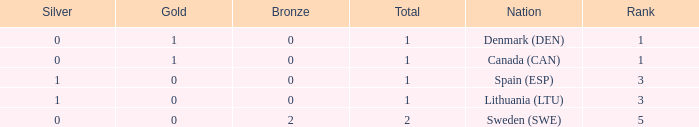What is the number of gold medals for Lithuania (ltu), when the total is more than 1? None. 